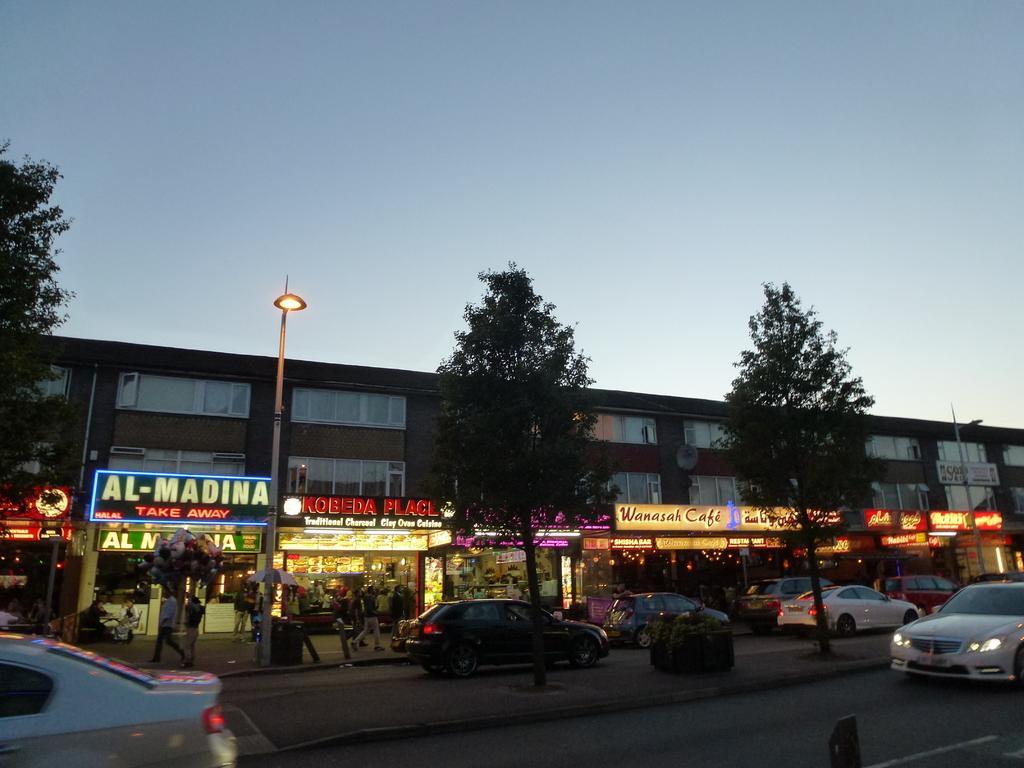Describe this image in one or two sentences. In the picture I can see a building, trees, vehicles on roads, pole lights, the grass, LED boards and some other objects on the ground. In the background I can see the sky. 